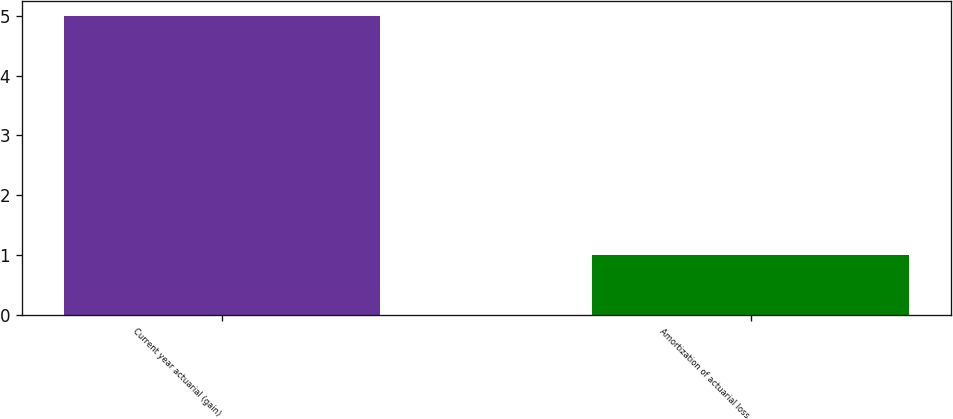Convert chart to OTSL. <chart><loc_0><loc_0><loc_500><loc_500><bar_chart><fcel>Current year actuarial (gain)<fcel>Amortization of actuarial loss<nl><fcel>5<fcel>1<nl></chart> 